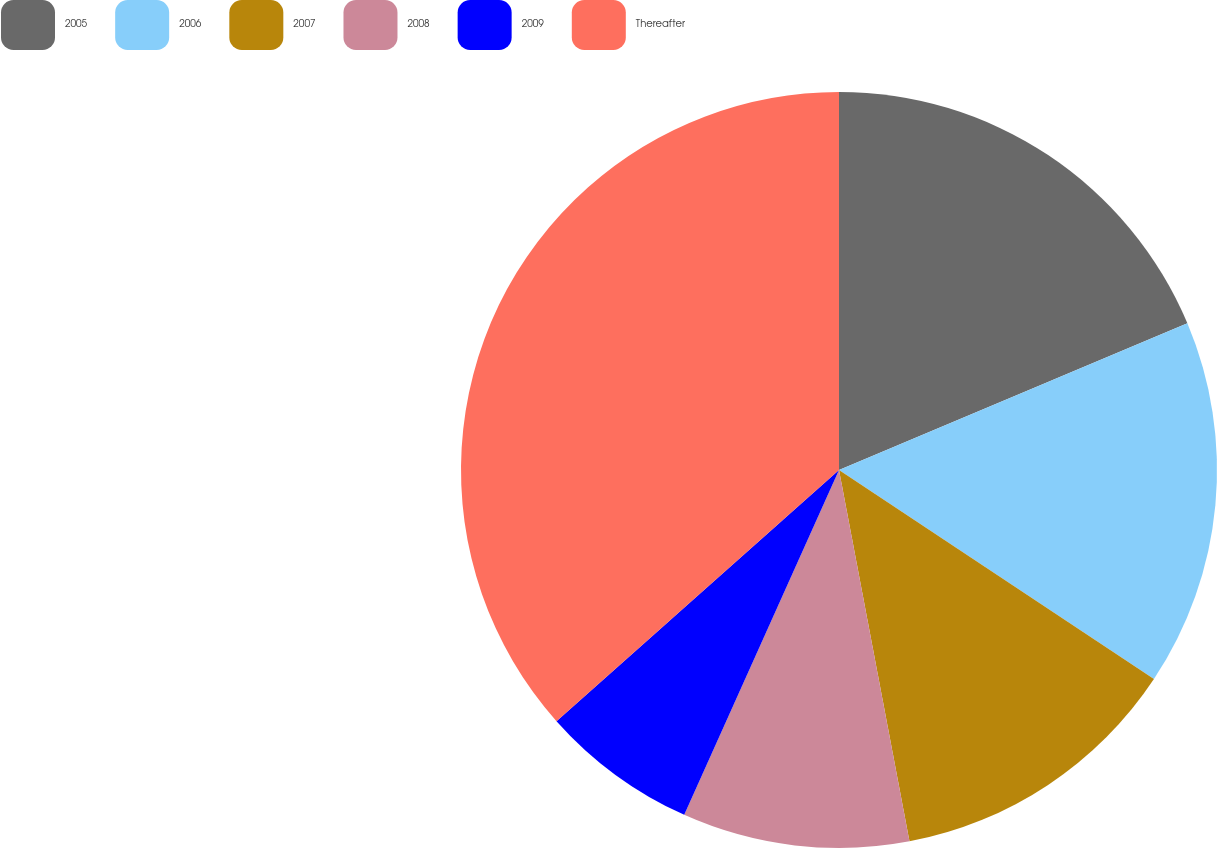Convert chart. <chart><loc_0><loc_0><loc_500><loc_500><pie_chart><fcel>2005<fcel>2006<fcel>2007<fcel>2008<fcel>2009<fcel>Thereafter<nl><fcel>18.66%<fcel>15.67%<fcel>12.69%<fcel>9.7%<fcel>6.72%<fcel>36.57%<nl></chart> 